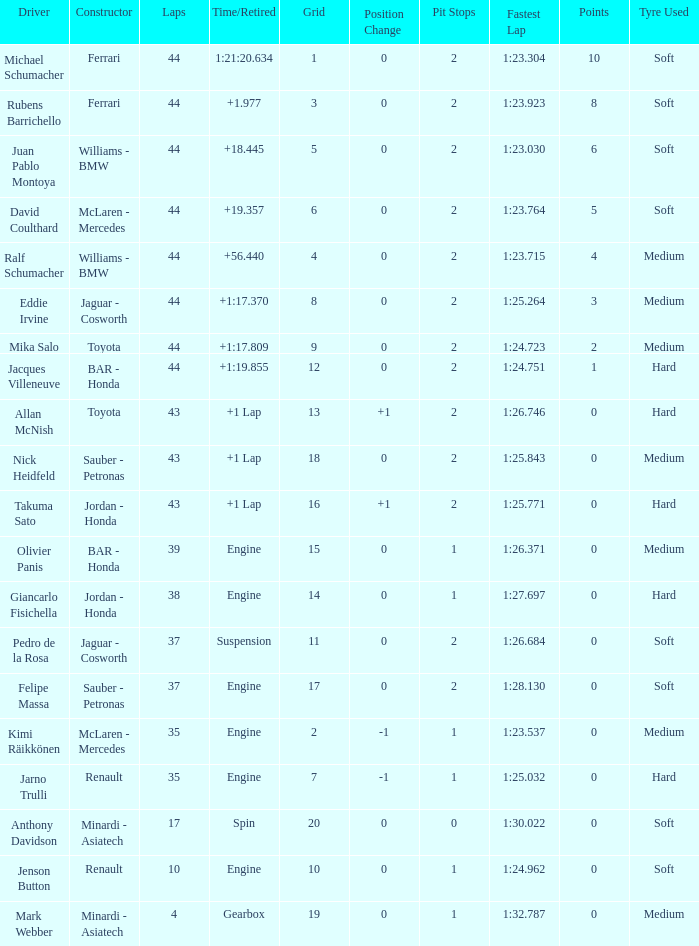What was the retired time on someone who had 43 laps on a grip of 18? +1 Lap. 